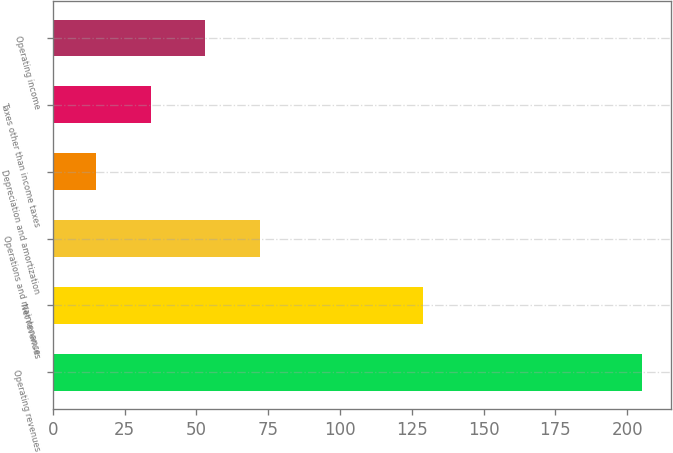<chart> <loc_0><loc_0><loc_500><loc_500><bar_chart><fcel>Operating revenues<fcel>Net revenues<fcel>Operations and maintenance<fcel>Depreciation and amortization<fcel>Taxes other than income taxes<fcel>Operating income<nl><fcel>205<fcel>129<fcel>72<fcel>15<fcel>34<fcel>53<nl></chart> 